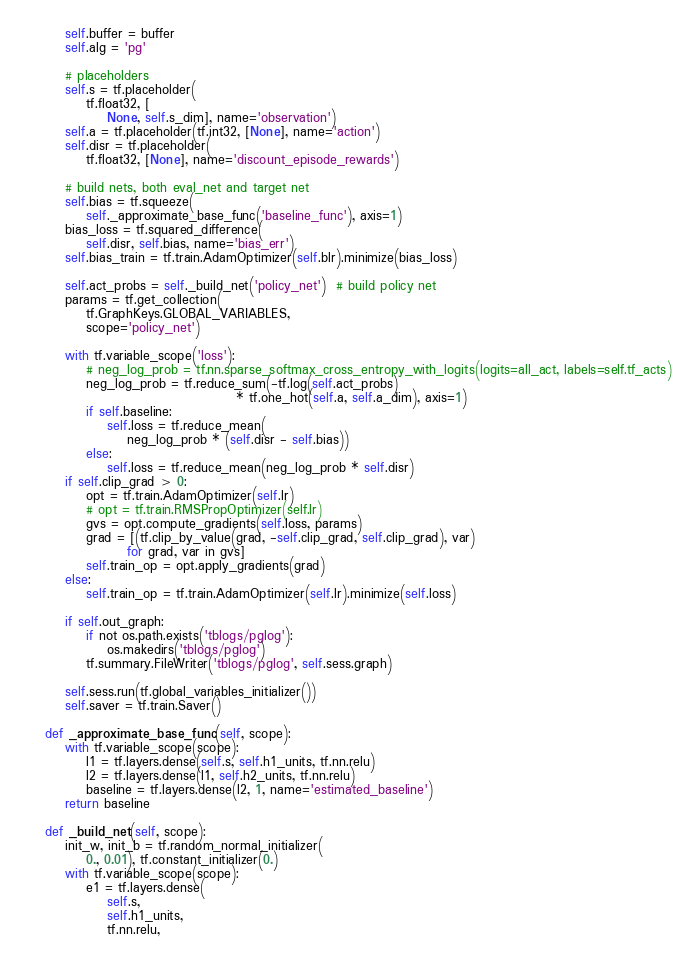Convert code to text. <code><loc_0><loc_0><loc_500><loc_500><_Python_>        self.buffer = buffer
        self.alg = 'pg'

        # placeholders
        self.s = tf.placeholder(
            tf.float32, [
                None, self.s_dim], name='observation')
        self.a = tf.placeholder(tf.int32, [None], name='action')
        self.disr = tf.placeholder(
            tf.float32, [None], name='discount_episode_rewards')

        # build nets, both eval_net and target net
        self.bias = tf.squeeze(
            self._approximate_base_func('baseline_func'), axis=1)
        bias_loss = tf.squared_difference(
            self.disr, self.bias, name='bias_err')
        self.bias_train = tf.train.AdamOptimizer(self.blr).minimize(bias_loss)

        self.act_probs = self._build_net('policy_net')  # build policy net
        params = tf.get_collection(
            tf.GraphKeys.GLOBAL_VARIABLES,
            scope='policy_net')

        with tf.variable_scope('loss'):
            # neg_log_prob = tf.nn.sparse_softmax_cross_entropy_with_logits(logits=all_act, labels=self.tf_acts)
            neg_log_prob = tf.reduce_sum(-tf.log(self.act_probs)
                                         * tf.one_hot(self.a, self.a_dim), axis=1)
            if self.baseline:
                self.loss = tf.reduce_mean(
                    neg_log_prob * (self.disr - self.bias))
            else:
                self.loss = tf.reduce_mean(neg_log_prob * self.disr)
        if self.clip_grad > 0:
            opt = tf.train.AdamOptimizer(self.lr)
            # opt = tf.train.RMSPropOptimizer(self.lr)
            gvs = opt.compute_gradients(self.loss, params)
            grad = [(tf.clip_by_value(grad, -self.clip_grad, self.clip_grad), var)
                    for grad, var in gvs]
            self.train_op = opt.apply_gradients(grad)
        else:
            self.train_op = tf.train.AdamOptimizer(self.lr).minimize(self.loss)

        if self.out_graph:
            if not os.path.exists('tblogs/pglog'):
                os.makedirs('tblogs/pglog')
            tf.summary.FileWriter('tblogs/pglog', self.sess.graph)

        self.sess.run(tf.global_variables_initializer())
        self.saver = tf.train.Saver()

    def _approximate_base_func(self, scope):
        with tf.variable_scope(scope):
            l1 = tf.layers.dense(self.s, self.h1_units, tf.nn.relu)
            l2 = tf.layers.dense(l1, self.h2_units, tf.nn.relu)
            baseline = tf.layers.dense(l2, 1, name='estimated_baseline')
        return baseline

    def _build_net(self, scope):
        init_w, init_b = tf.random_normal_initializer(
            0., 0.01), tf.constant_initializer(0.)
        with tf.variable_scope(scope):
            e1 = tf.layers.dense(
                self.s,
                self.h1_units,
                tf.nn.relu,</code> 